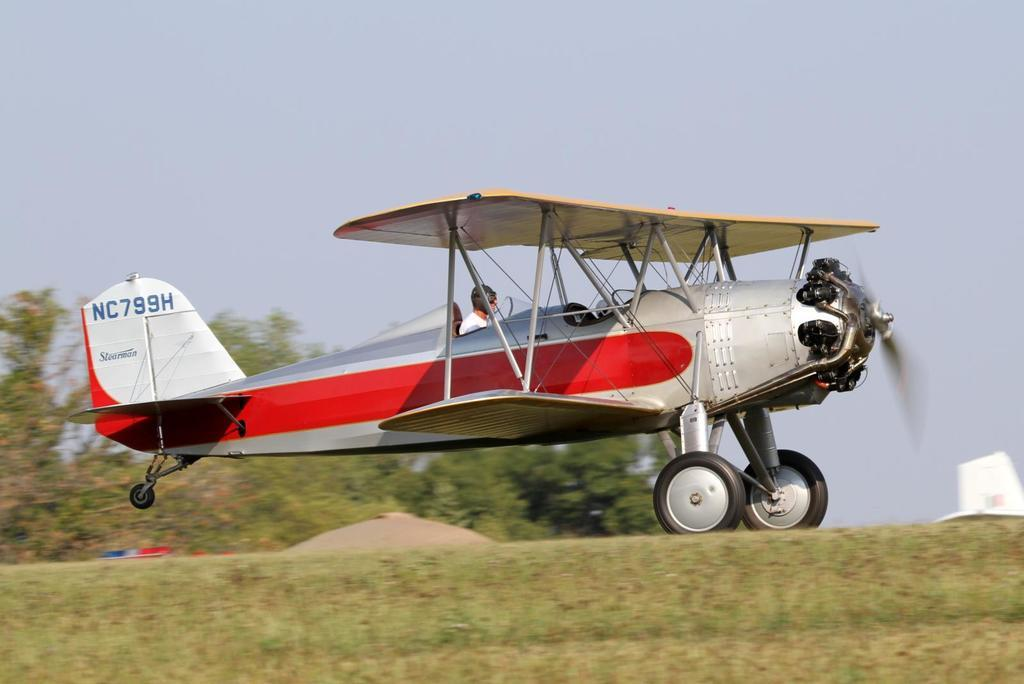<image>
Give a short and clear explanation of the subsequent image. An old single prop plane, NC799H, is about to take off from the grass field. 